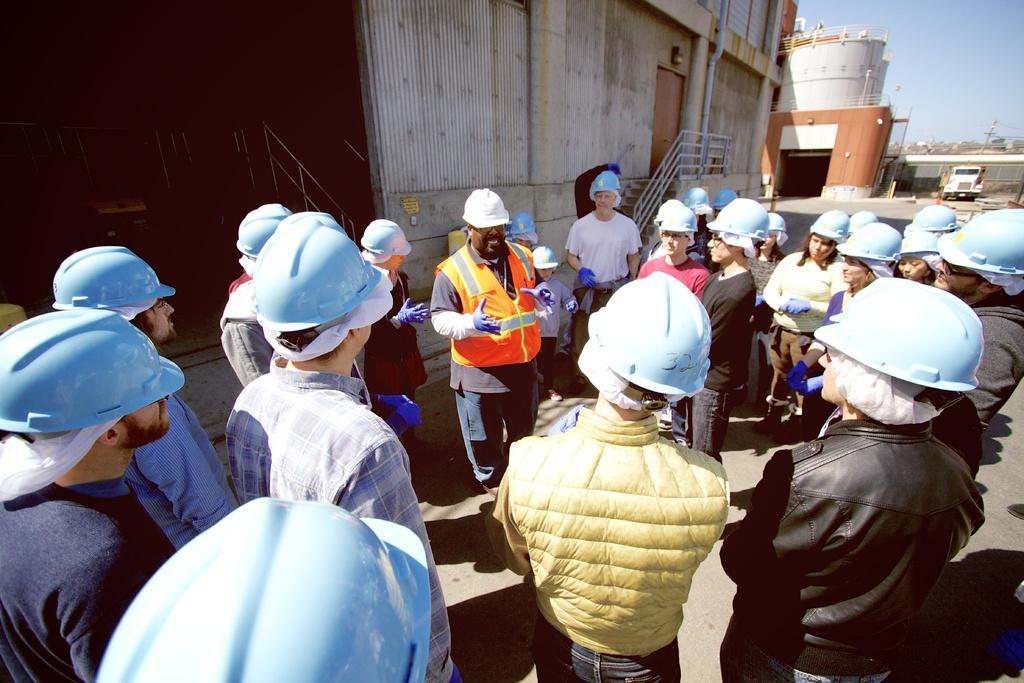Could you give a brief overview of what you see in this image? At the bottom of this image, there are persons in different color dresses. Some of them are wearing blue color helmets. The rest of them are wearing white color helmets. In the background, there is a shed, a tank, a pipe, a vehicle, a pole and there are clouds in the sky. 